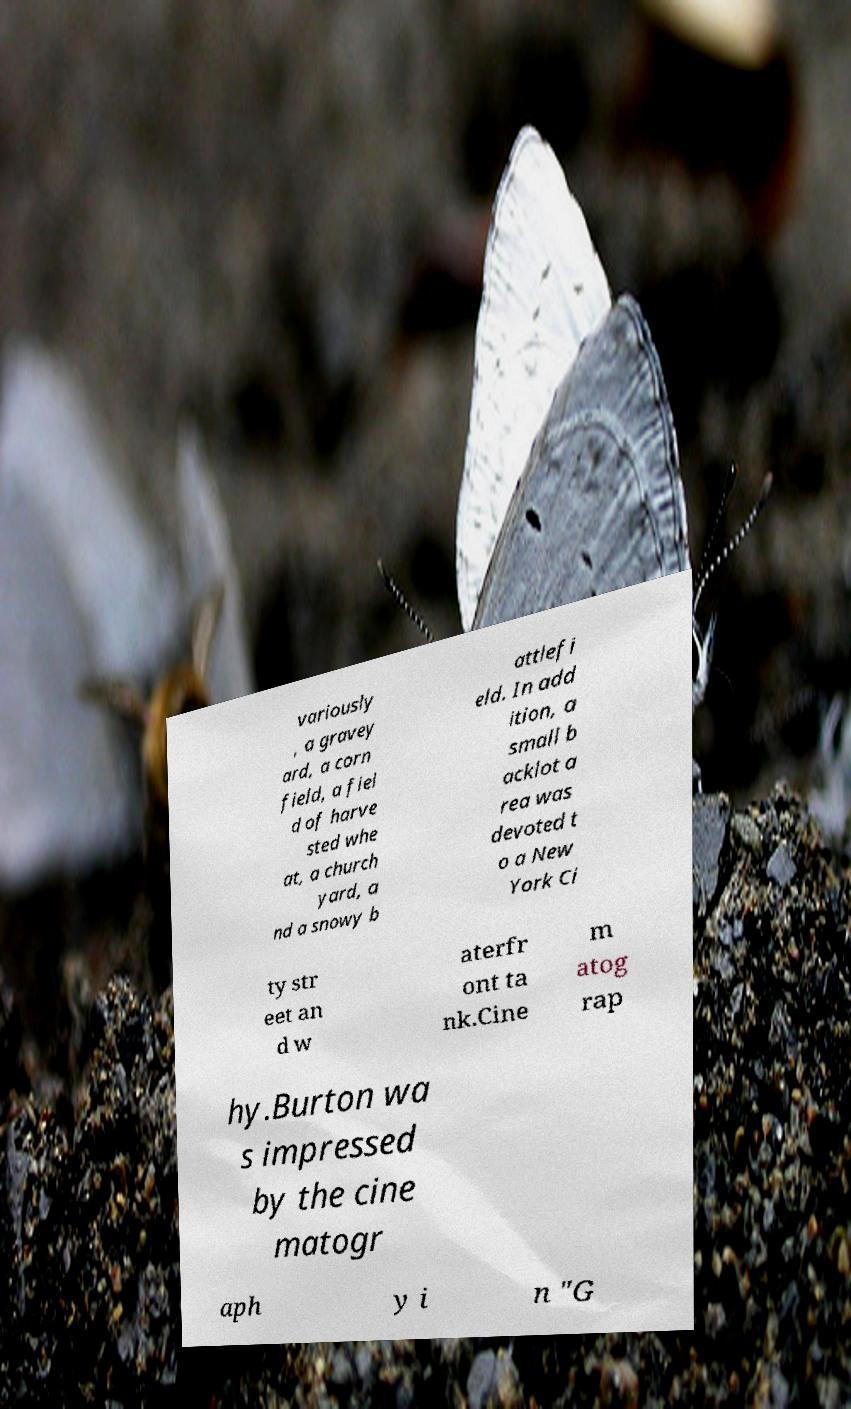I need the written content from this picture converted into text. Can you do that? variously , a gravey ard, a corn field, a fiel d of harve sted whe at, a church yard, a nd a snowy b attlefi eld. In add ition, a small b acklot a rea was devoted t o a New York Ci ty str eet an d w aterfr ont ta nk.Cine m atog rap hy.Burton wa s impressed by the cine matogr aph y i n "G 